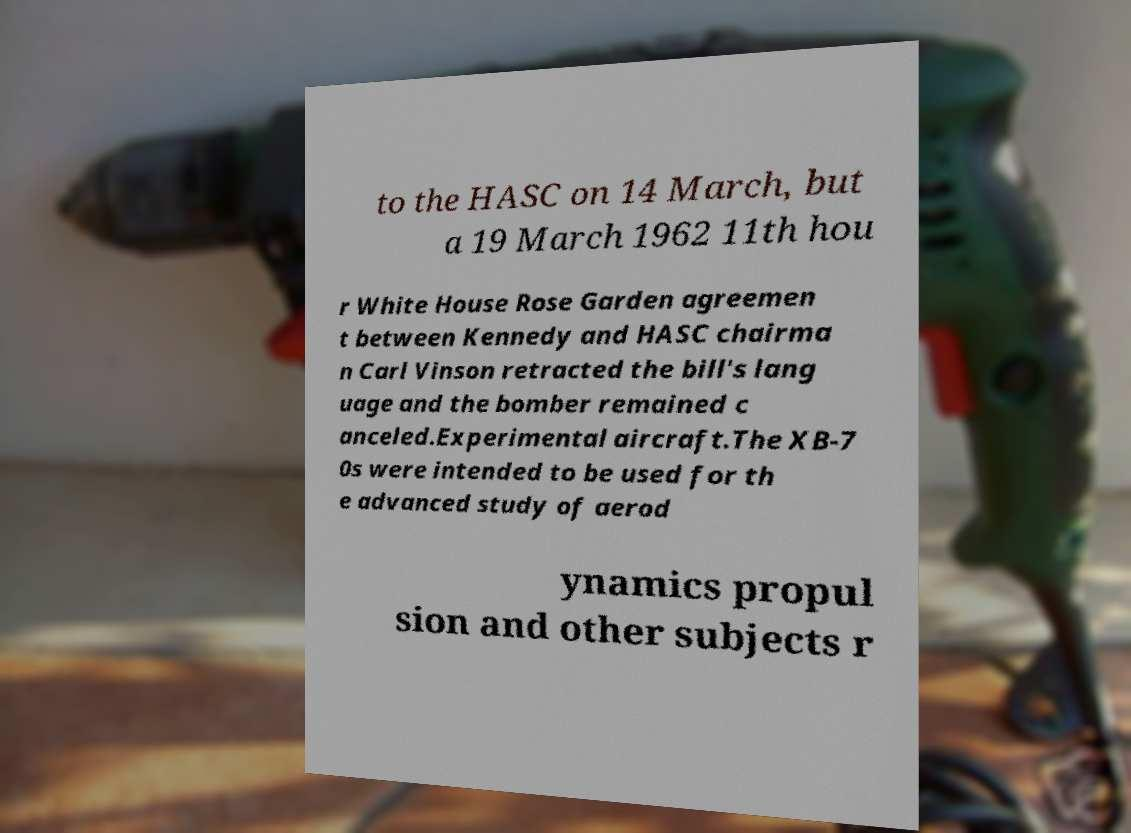Can you read and provide the text displayed in the image?This photo seems to have some interesting text. Can you extract and type it out for me? to the HASC on 14 March, but a 19 March 1962 11th hou r White House Rose Garden agreemen t between Kennedy and HASC chairma n Carl Vinson retracted the bill's lang uage and the bomber remained c anceled.Experimental aircraft.The XB-7 0s were intended to be used for th e advanced study of aerod ynamics propul sion and other subjects r 